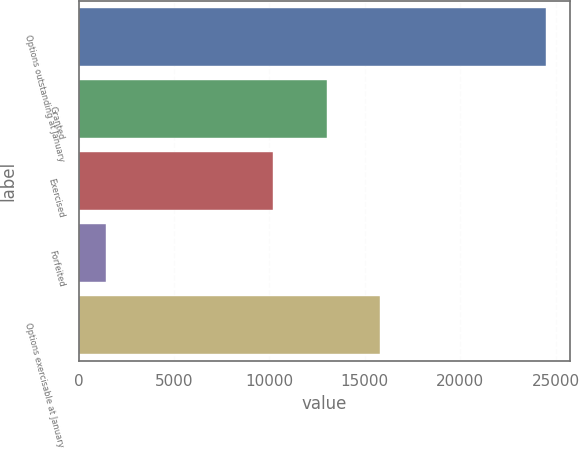Convert chart to OTSL. <chart><loc_0><loc_0><loc_500><loc_500><bar_chart><fcel>Options outstanding at January<fcel>Granted<fcel>Exercised<fcel>Forfeited<fcel>Options exercisable at January<nl><fcel>24506<fcel>12993.3<fcel>10197<fcel>1411<fcel>15789.6<nl></chart> 